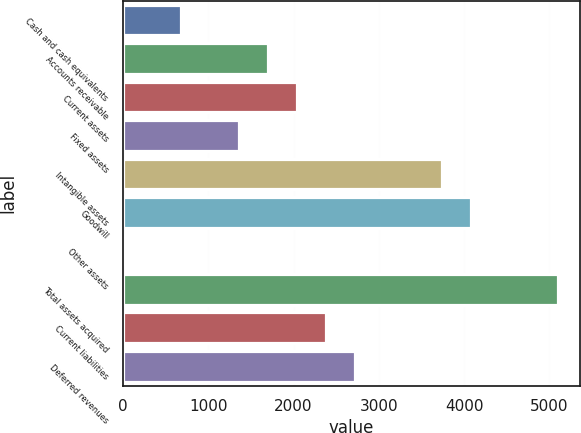Convert chart to OTSL. <chart><loc_0><loc_0><loc_500><loc_500><bar_chart><fcel>Cash and cash equivalents<fcel>Accounts receivable<fcel>Current assets<fcel>Fixed assets<fcel>Intangible assets<fcel>Goodwill<fcel>Other assets<fcel>Total assets acquired<fcel>Current liabilities<fcel>Deferred revenues<nl><fcel>681.88<fcel>1701.7<fcel>2041.64<fcel>1361.76<fcel>3741.34<fcel>4081.28<fcel>2<fcel>5101.1<fcel>2381.58<fcel>2721.52<nl></chart> 